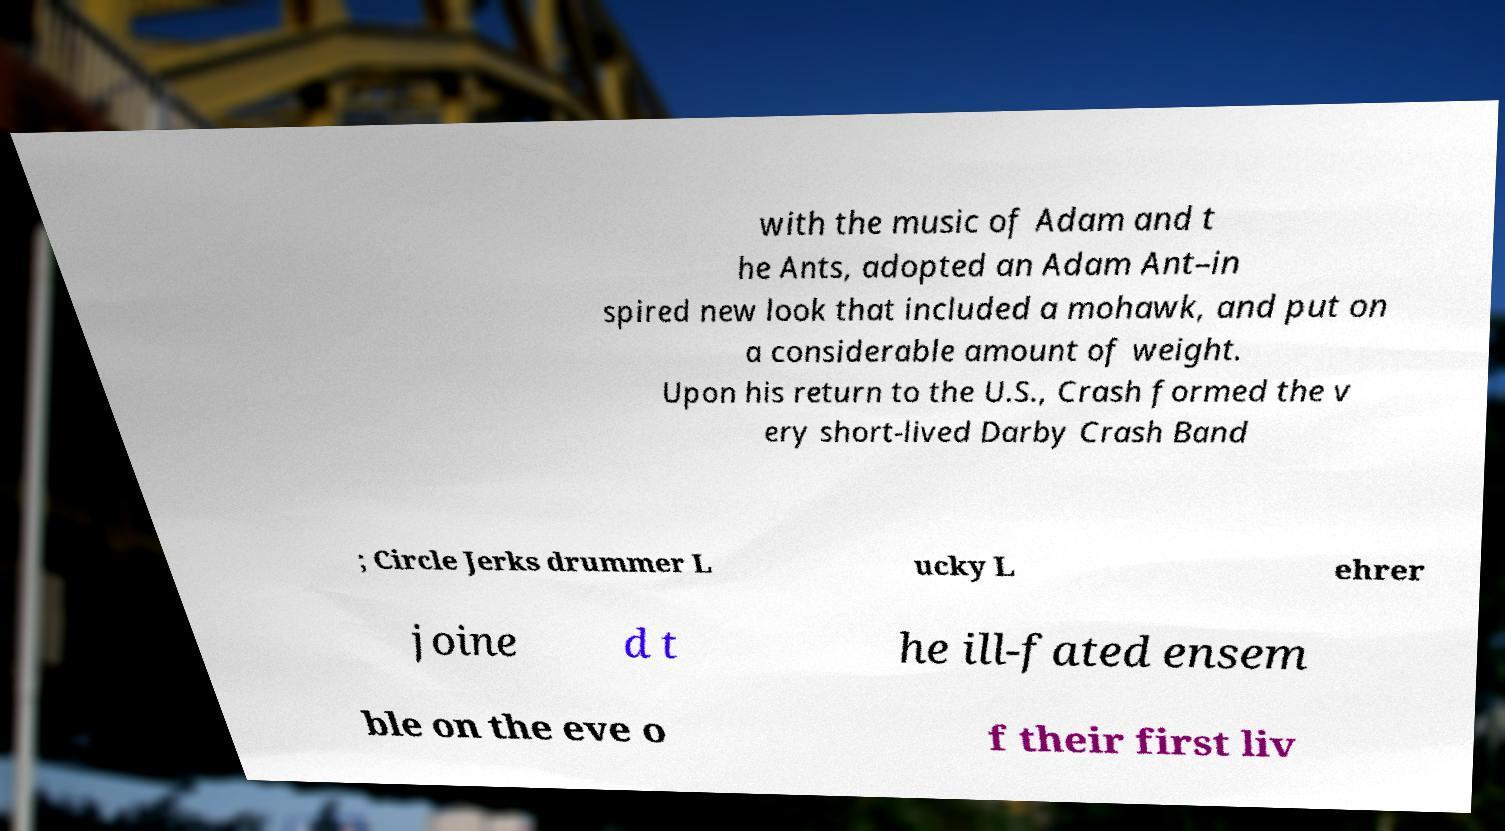Please identify and transcribe the text found in this image. with the music of Adam and t he Ants, adopted an Adam Ant–in spired new look that included a mohawk, and put on a considerable amount of weight. Upon his return to the U.S., Crash formed the v ery short-lived Darby Crash Band ; Circle Jerks drummer L ucky L ehrer joine d t he ill-fated ensem ble on the eve o f their first liv 